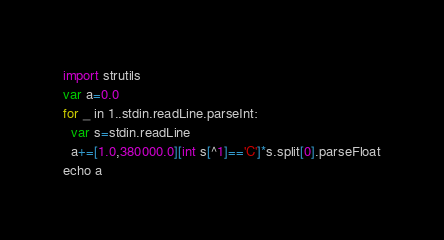Convert code to text. <code><loc_0><loc_0><loc_500><loc_500><_Nim_>import strutils
var a=0.0
for _ in 1..stdin.readLine.parseInt:
  var s=stdin.readLine
  a+=[1.0,380000.0][int s[^1]=='C']*s.split[0].parseFloat
echo a</code> 